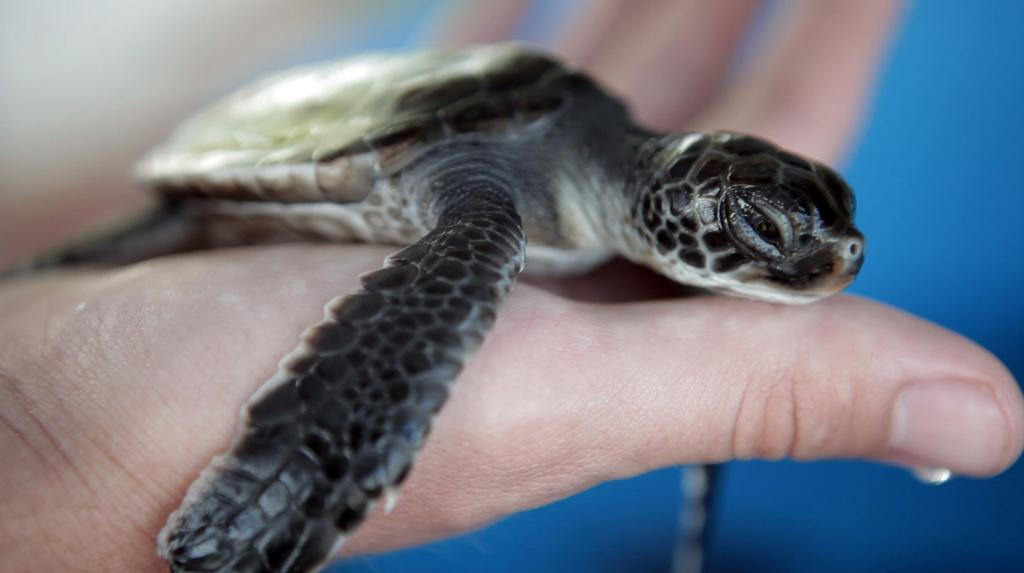What animal is in the image? There is a turtle in the image. How is the turtle being held in the image? The turtle is being held by a person. What color is the background of the image? The background of the image is blue. What is the color of the turtle? The turtle is black in color. What type of bag is the turtle carrying in the image? There is no bag present in the image; the turtle is being held by a person. 